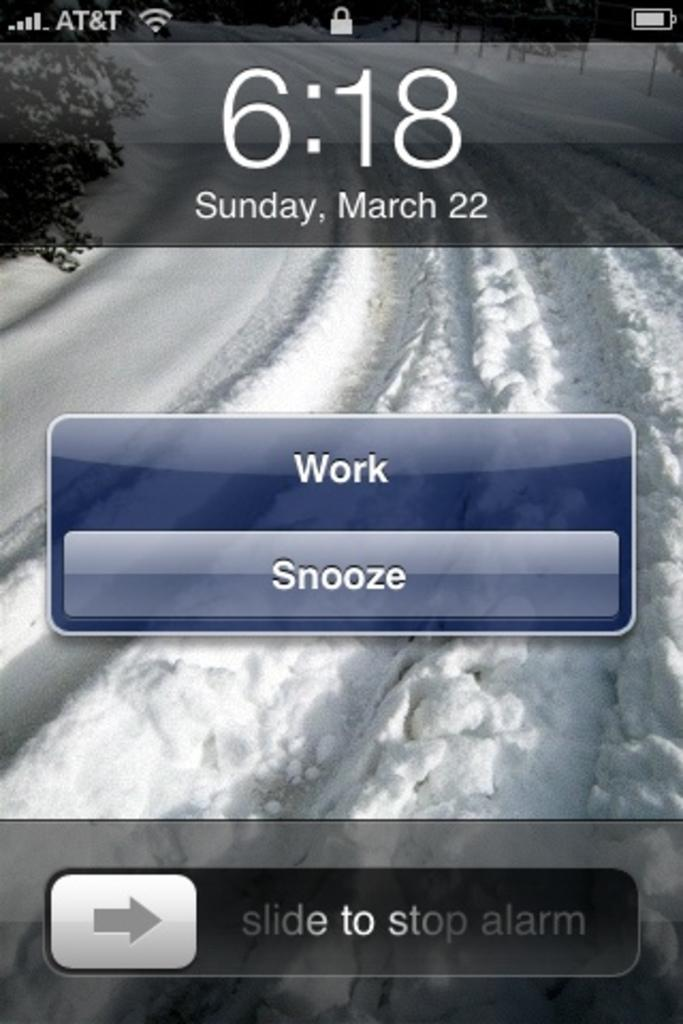<image>
Give a short and clear explanation of the subsequent image. A phone screen shows that the time is 6:18 on Sunday, March 22. 